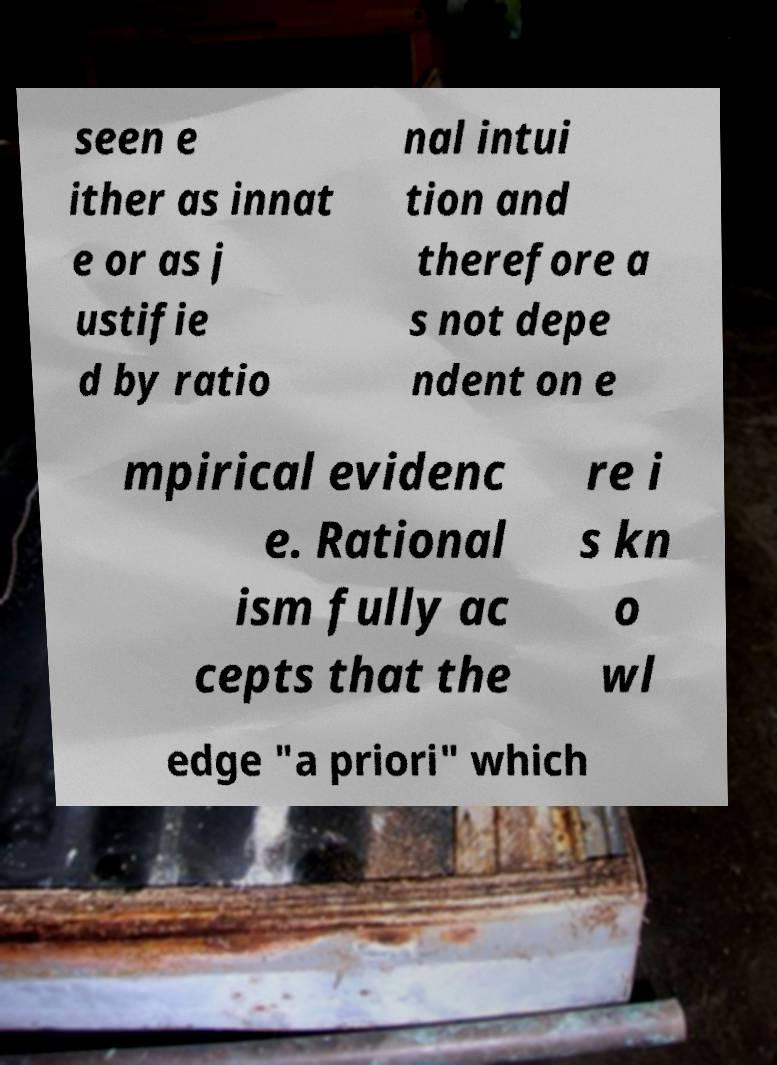Can you read and provide the text displayed in the image?This photo seems to have some interesting text. Can you extract and type it out for me? seen e ither as innat e or as j ustifie d by ratio nal intui tion and therefore a s not depe ndent on e mpirical evidenc e. Rational ism fully ac cepts that the re i s kn o wl edge "a priori" which 